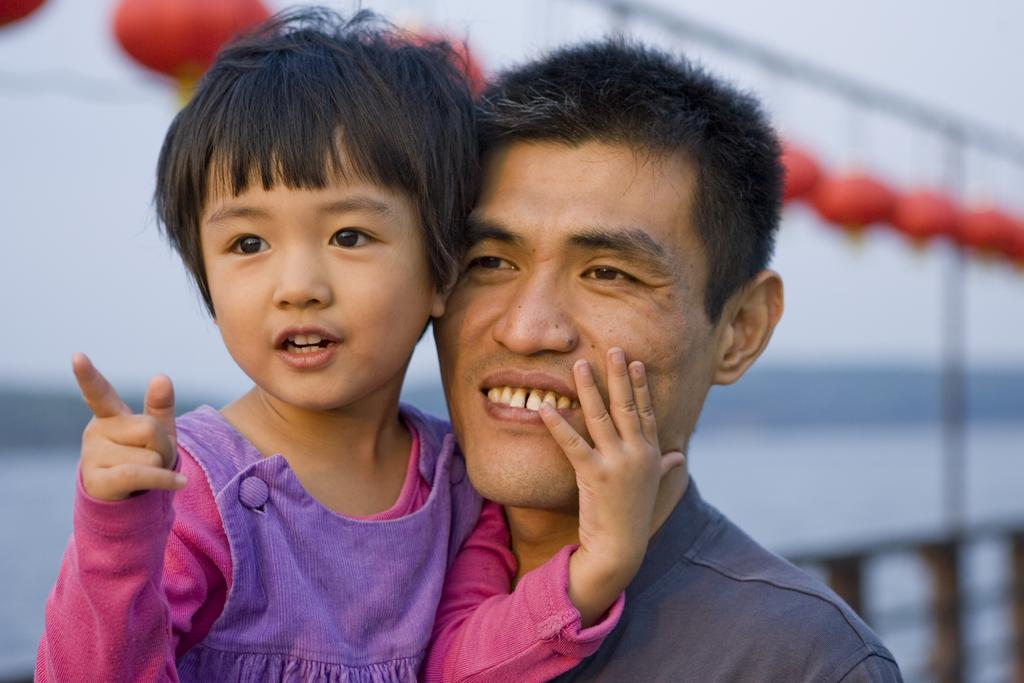Who are the two people in the center of the image? There is a man and a girl in the center of the image. What is located at the bottom of the image? There is a bridge at the bottom of the image. What can be seen in the background of the image? There are balloons, poles, and water visible in the background of the image. How does the man measure the distance between the poles in the image? There is no indication in the image that the man is measuring anything, let alone the distance between poles. 